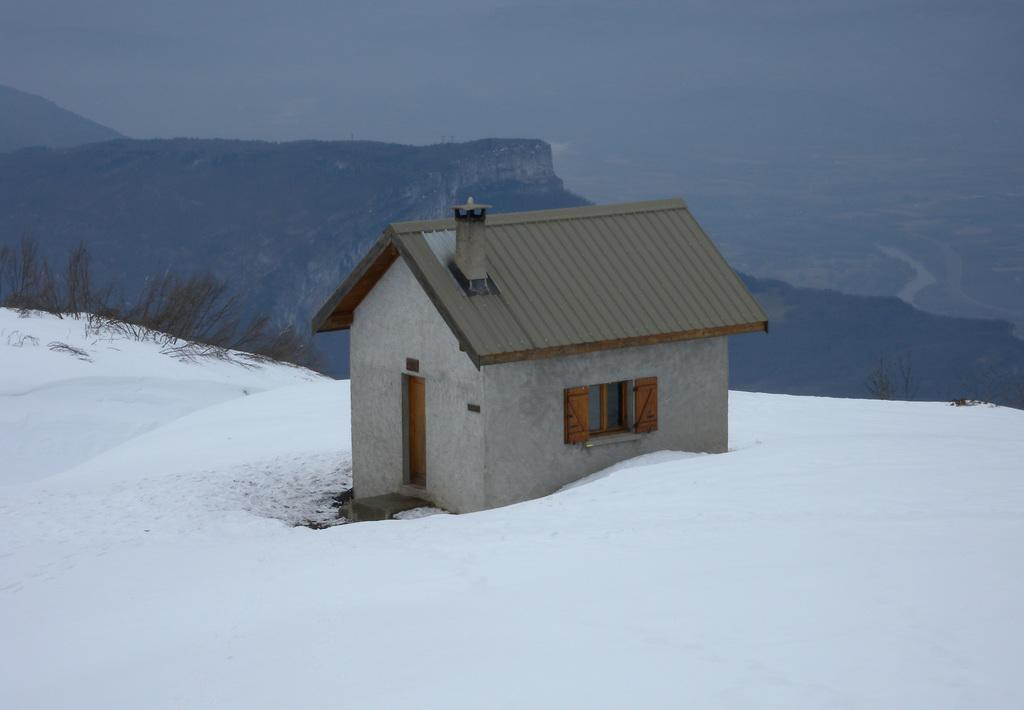What type of structure is in the image? There is a small house in the image. Where is the house located? The house is in the snow. What can be seen in the background of the image? There are mountains in the background of the image. Is there any vegetation visible in the snow? Yes, there is a small patch of grass in the snow on the left side of the image. How much money is hidden under the grass in the image? There is no mention of money or any hidden objects in the image; it only shows a small house, snow, mountains, and a patch of grass. 